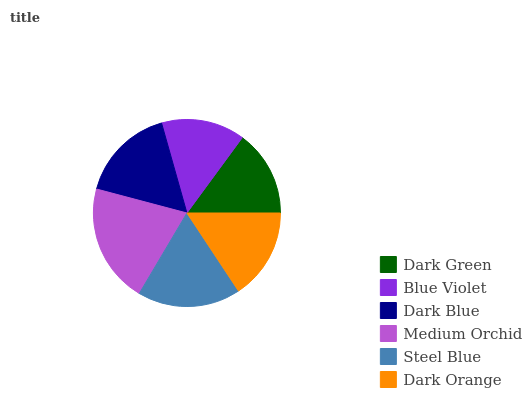Is Blue Violet the minimum?
Answer yes or no. Yes. Is Medium Orchid the maximum?
Answer yes or no. Yes. Is Dark Blue the minimum?
Answer yes or no. No. Is Dark Blue the maximum?
Answer yes or no. No. Is Dark Blue greater than Blue Violet?
Answer yes or no. Yes. Is Blue Violet less than Dark Blue?
Answer yes or no. Yes. Is Blue Violet greater than Dark Blue?
Answer yes or no. No. Is Dark Blue less than Blue Violet?
Answer yes or no. No. Is Dark Blue the high median?
Answer yes or no. Yes. Is Dark Orange the low median?
Answer yes or no. Yes. Is Medium Orchid the high median?
Answer yes or no. No. Is Steel Blue the low median?
Answer yes or no. No. 